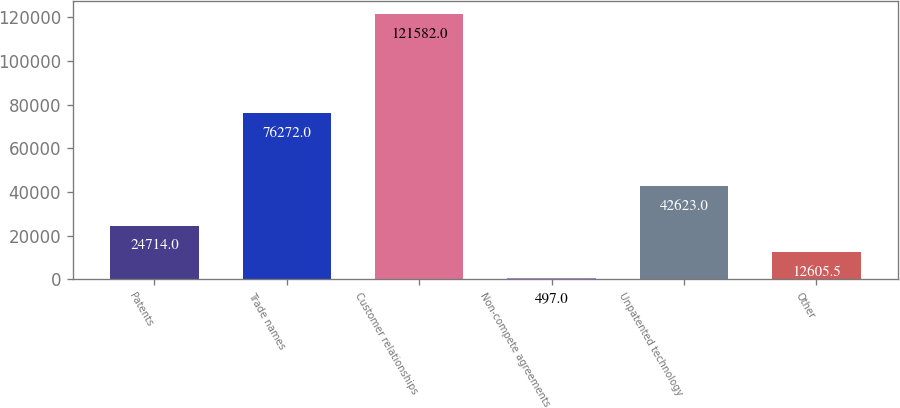<chart> <loc_0><loc_0><loc_500><loc_500><bar_chart><fcel>Patents<fcel>Trade names<fcel>Customer relationships<fcel>Non-compete agreements<fcel>Unpatented technology<fcel>Other<nl><fcel>24714<fcel>76272<fcel>121582<fcel>497<fcel>42623<fcel>12605.5<nl></chart> 